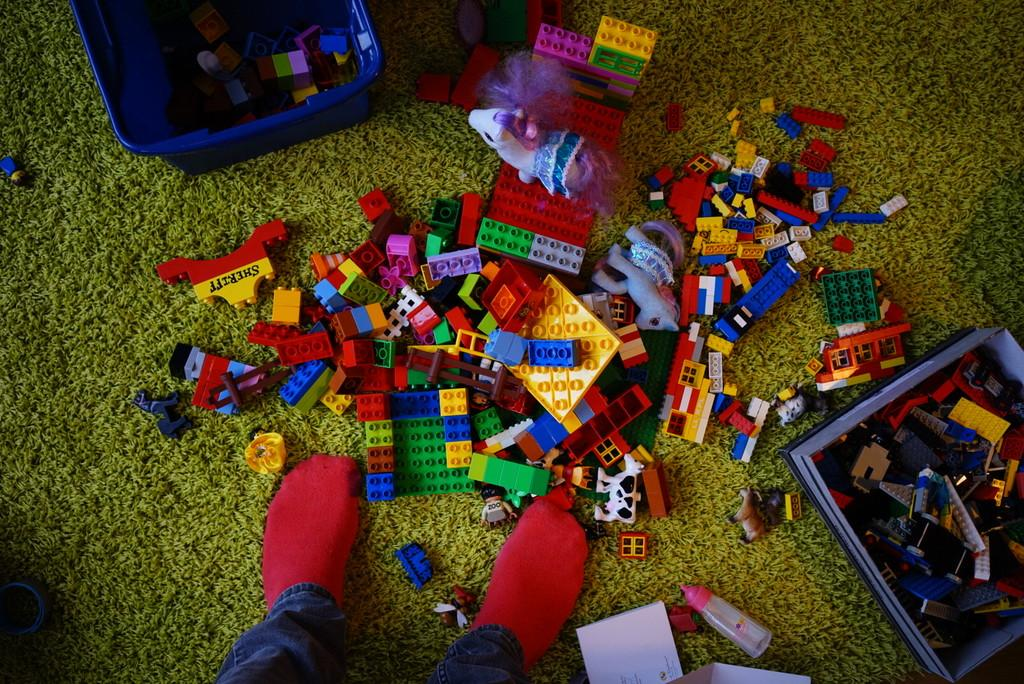What is on the floor in the image? There is a mat in the picture. What else can be seen on the floor? There are many toys present in the image. How are the toys organized or contained? There are two boxes with the toys. Is there anyone interacting with the toys in the image? Yes, there is a person standing near the toys. What type of drum can be heard in the background of the image? There is no drum or sound present in the image; it is a still picture of a mat and toys. 